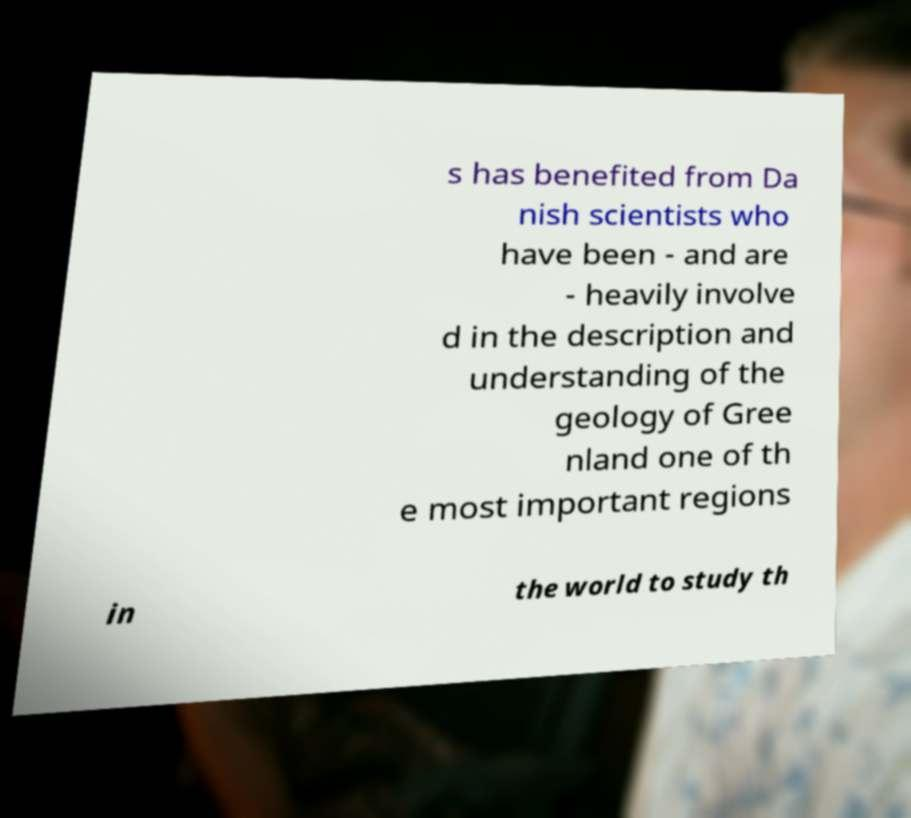Can you accurately transcribe the text from the provided image for me? s has benefited from Da nish scientists who have been - and are - heavily involve d in the description and understanding of the geology of Gree nland one of th e most important regions in the world to study th 